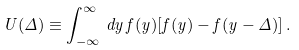<formula> <loc_0><loc_0><loc_500><loc_500>U ( \Delta ) \equiv \int _ { - \infty } ^ { \infty } \, d y \, f ( y ) [ f ( y ) - f ( y - \Delta ) ] \, .</formula> 